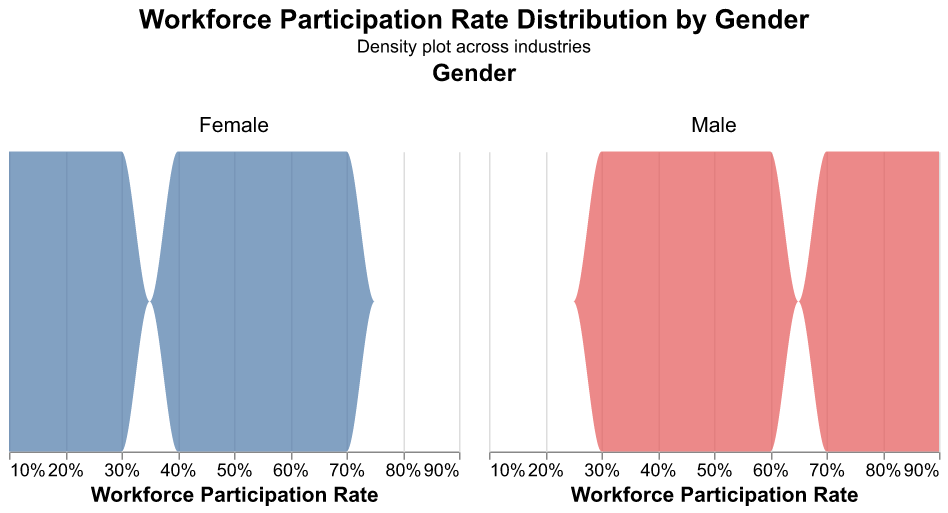Which industry has the highest workforce participation rate for males? By examining the figure, identify the industry with the maximum peak on the male density plot. The peak corresponding to the highest male workforce participation rate is in the construction industry.
Answer: Construction Which industry has the highest workforce participation rate for females? By inspecting the figure, find the industry with the highest peak on the female density plot. The maximum workforce participation rate for females is in the healthcare industry.
Answer: Healthcare What is the range of workforce participation rates for females across the industries? Observe the range of the workforce participation rates on the x-axis for the female density plot. The range starts from the lowest rate in construction (0.10) to the highest in healthcare (0.70).
Answer: 0.10 to 0.70 Compare the workforce participation rates in the energy industry for males and females. Which gender has a higher rate? Look at the density plot for the energy industry under both genders. The male density plot has a higher peak at 0.85 compared to the female at 0.15.
Answer: Males In which industry is the workforce participation rate equal for both genders? Identify the industry where the peaks on both the male and female density plots align. This occurs in the public services industry.
Answer: Public Services Which industry has a greater difference between male and female workforce participation rates? Calculate the differences in workforce participation rates for each industry and compare them. The construction industry shows the largest gap: 0.90 (male) - 0.10 (female) = 0.80.
Answer: Construction What is the average workforce participation rate for males across all industries? Calculate the sum of male workforce participation rates across all industries and divide by the number of industries: (0.75 + 0.30 + 0.60 + 0.80 + 0.35 + 0.45 + 0.90 + 0.55 + 0.40 + 0.85 + 0.70 + 0.50) / 12 = 6.15 / 12 = 0.5125.
Answer: 0.5125 Which industry has a more balanced workforce participation rate between genders? Look for the industry where the peaks for both genders in the density plot are closest. The public services industry has a balanced workforce participation rate (0.50 for both genders).
Answer: Public Services 